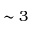<formula> <loc_0><loc_0><loc_500><loc_500>\sim 3</formula> 